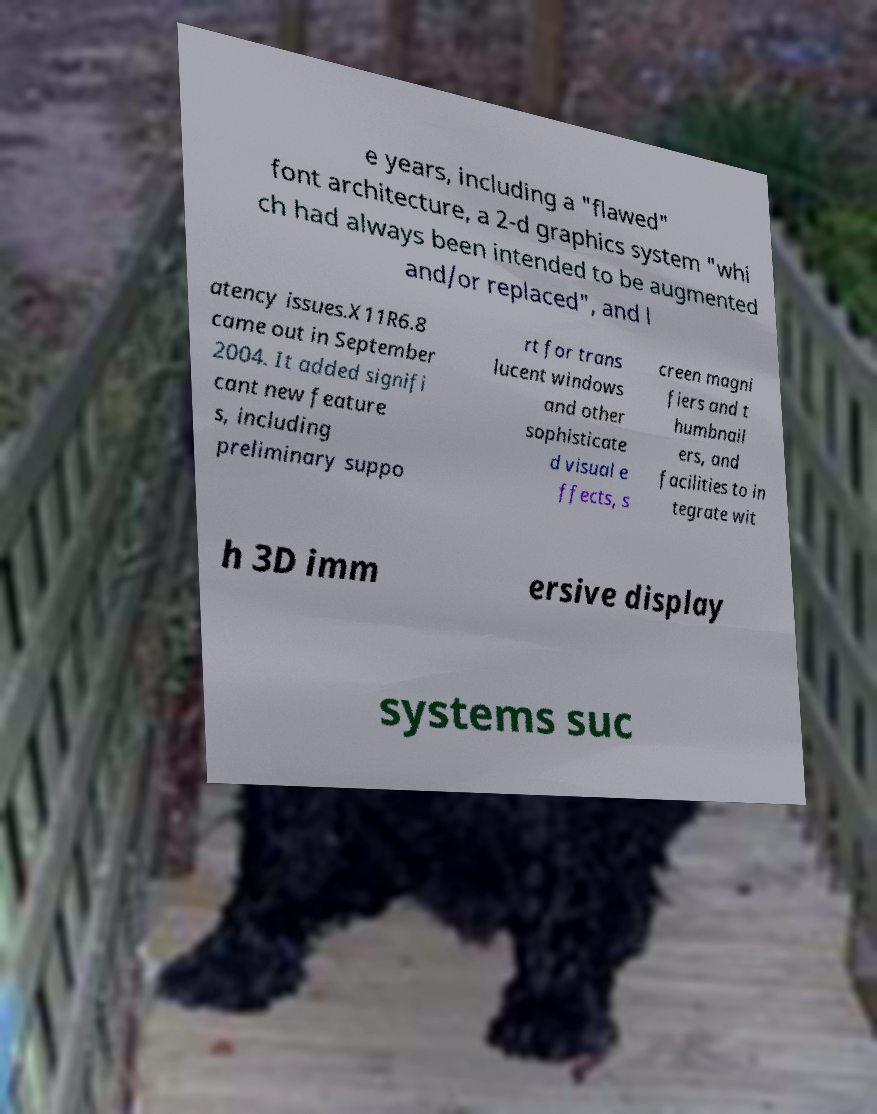Can you read and provide the text displayed in the image?This photo seems to have some interesting text. Can you extract and type it out for me? e years, including a "flawed" font architecture, a 2-d graphics system "whi ch had always been intended to be augmented and/or replaced", and l atency issues.X11R6.8 came out in September 2004. It added signifi cant new feature s, including preliminary suppo rt for trans lucent windows and other sophisticate d visual e ffects, s creen magni fiers and t humbnail ers, and facilities to in tegrate wit h 3D imm ersive display systems suc 